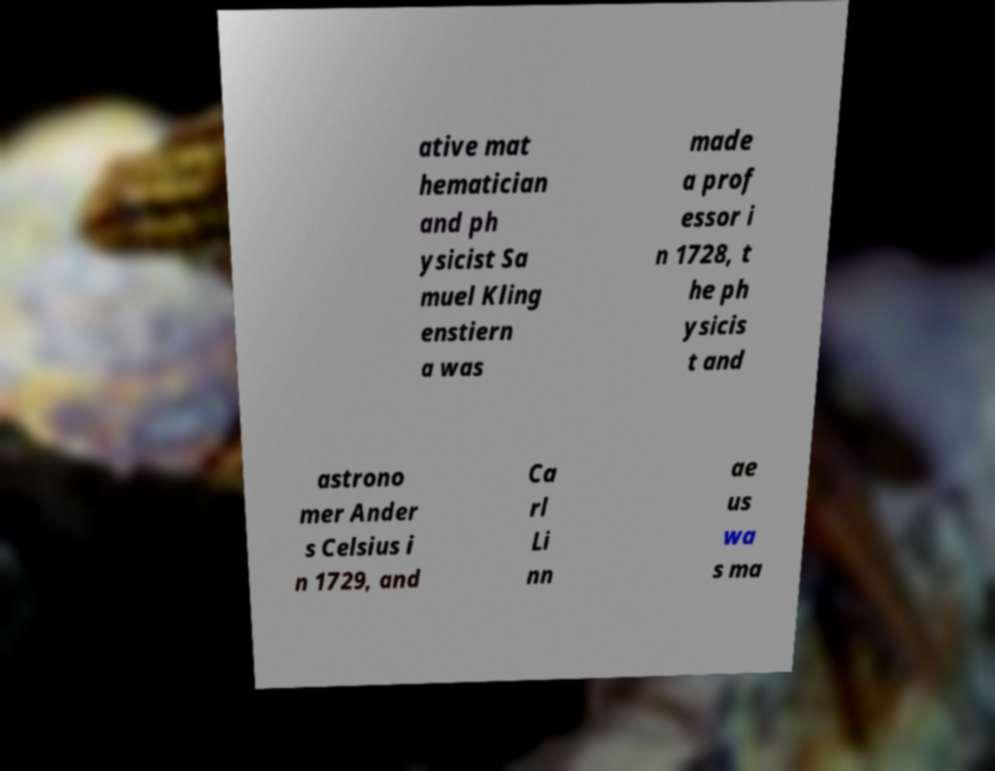For documentation purposes, I need the text within this image transcribed. Could you provide that? ative mat hematician and ph ysicist Sa muel Kling enstiern a was made a prof essor i n 1728, t he ph ysicis t and astrono mer Ander s Celsius i n 1729, and Ca rl Li nn ae us wa s ma 